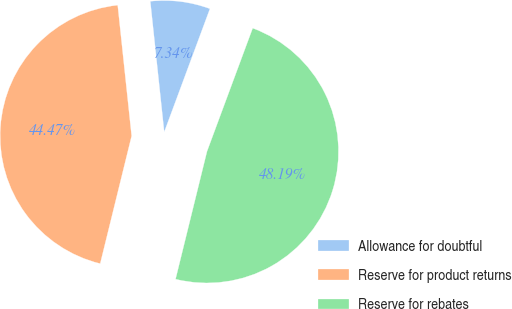Convert chart to OTSL. <chart><loc_0><loc_0><loc_500><loc_500><pie_chart><fcel>Allowance for doubtful<fcel>Reserve for product returns<fcel>Reserve for rebates<nl><fcel>7.34%<fcel>44.47%<fcel>48.19%<nl></chart> 